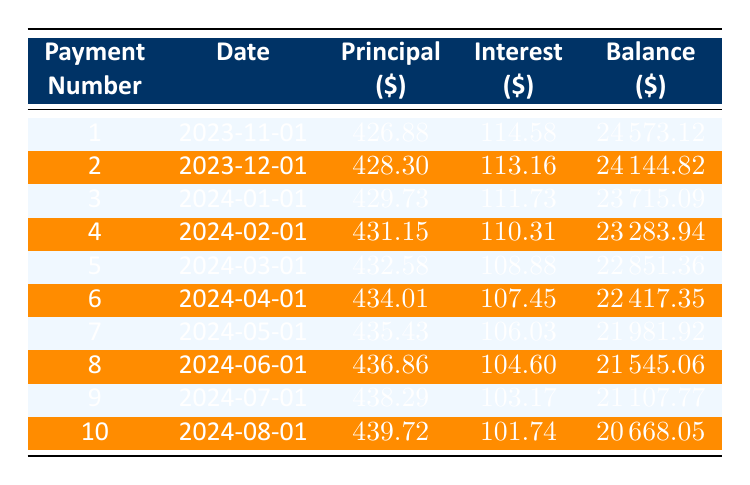What is the principal payment for the third month? In the table, look at the row corresponding to the third payment, which is payment number 3. The principal payment listed there is 429.73.
Answer: 429.73 What is the interest payment for the first payment? Checking the first row for payment number 1, the interest payment is 114.58.
Answer: 114.58 Is the balance after the second payment less than $24,000? The remaining balance after the second payment is 24144.82, which is less than 24,000. Therefore, the statement is true.
Answer: Yes What is the total principal paid after the first four payments? To find the total principal paid after the first four payments, sum the principal payments from rows 1 to 4: 426.88 + 428.30 + 429.73 + 431.15 = 1716.06.
Answer: 1716.06 What is the average interest payment for the first five months? The interest payments for the first five months are 114.58, 113.16, 111.73, 110.31, and 108.88. First, calculate the total interest: 114.58 + 113.16 + 111.73 + 110.31 + 108.88 = 558.66. Then divide by 5 to find the average: 558.66 / 5 = 111.732.
Answer: 111.73 What is the remaining balance after the fifth payment? The table shows that the remaining balance after the fifth payment (payment number 5) is 22851.36.
Answer: 22851.36 Was the principal payment for the eighth month greater than the seventh month? The principal payment for the eighth month is 436.86, which is greater than the principal payment for the seventh month, which is 435.43. Therefore, the statement is true.
Answer: Yes What is the total amount of interest paid in the first ten payments? To find this, sum the interest payments from all ten rows: 114.58 + 113.16 + 111.73 + 110.31 + 108.88 + 107.45 + 106.03 + 104.60 + 103.17 + 101.74 = 1,093.75.
Answer: 1093.75 What is the payment date for the fourth payment? The table indicates that the payment date for the fourth payment (payment number 4) is 2024-02-01.
Answer: 2024-02-01 